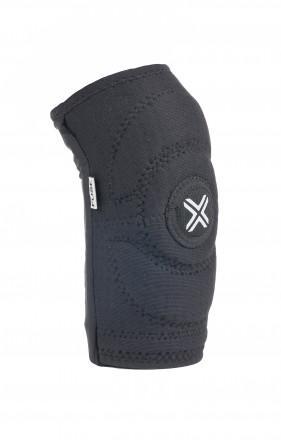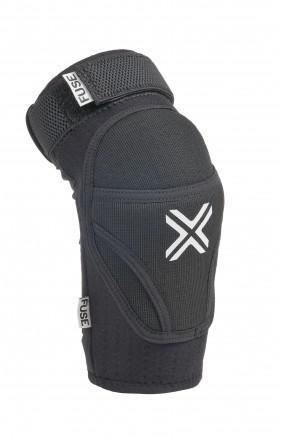The first image is the image on the left, the second image is the image on the right. Evaluate the accuracy of this statement regarding the images: "At least one padded gear has the letter X on it.". Is it true? Answer yes or no. Yes. The first image is the image on the left, the second image is the image on the right. Assess this claim about the two images: "One or more of the knee pads has an """"X"""" logo". Correct or not? Answer yes or no. Yes. 